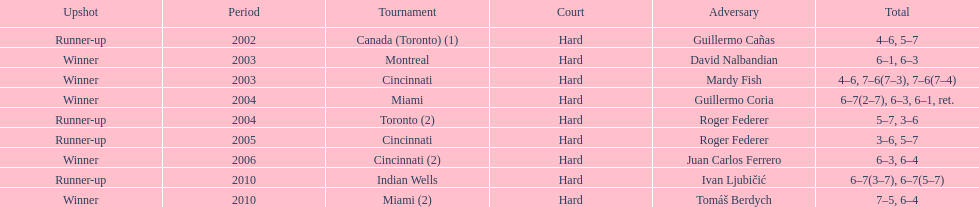What is his highest number of consecutive wins? 3. 